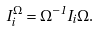Convert formula to latex. <formula><loc_0><loc_0><loc_500><loc_500>I _ { i } ^ { \Omega } = \Omega ^ { - 1 } I _ { i } \Omega .</formula> 